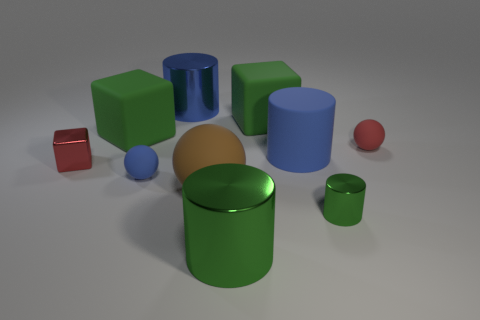Subtract all small blue rubber balls. How many balls are left? 2 Subtract all green cylinders. How many green blocks are left? 2 Subtract 1 cylinders. How many cylinders are left? 3 Subtract all blue balls. How many balls are left? 2 Subtract all blue blocks. Subtract all blue cylinders. How many blocks are left? 3 Subtract 0 brown cylinders. How many objects are left? 10 Subtract all balls. How many objects are left? 7 Subtract all green matte things. Subtract all small red rubber balls. How many objects are left? 7 Add 2 blue matte things. How many blue matte things are left? 4 Add 5 large blue objects. How many large blue objects exist? 7 